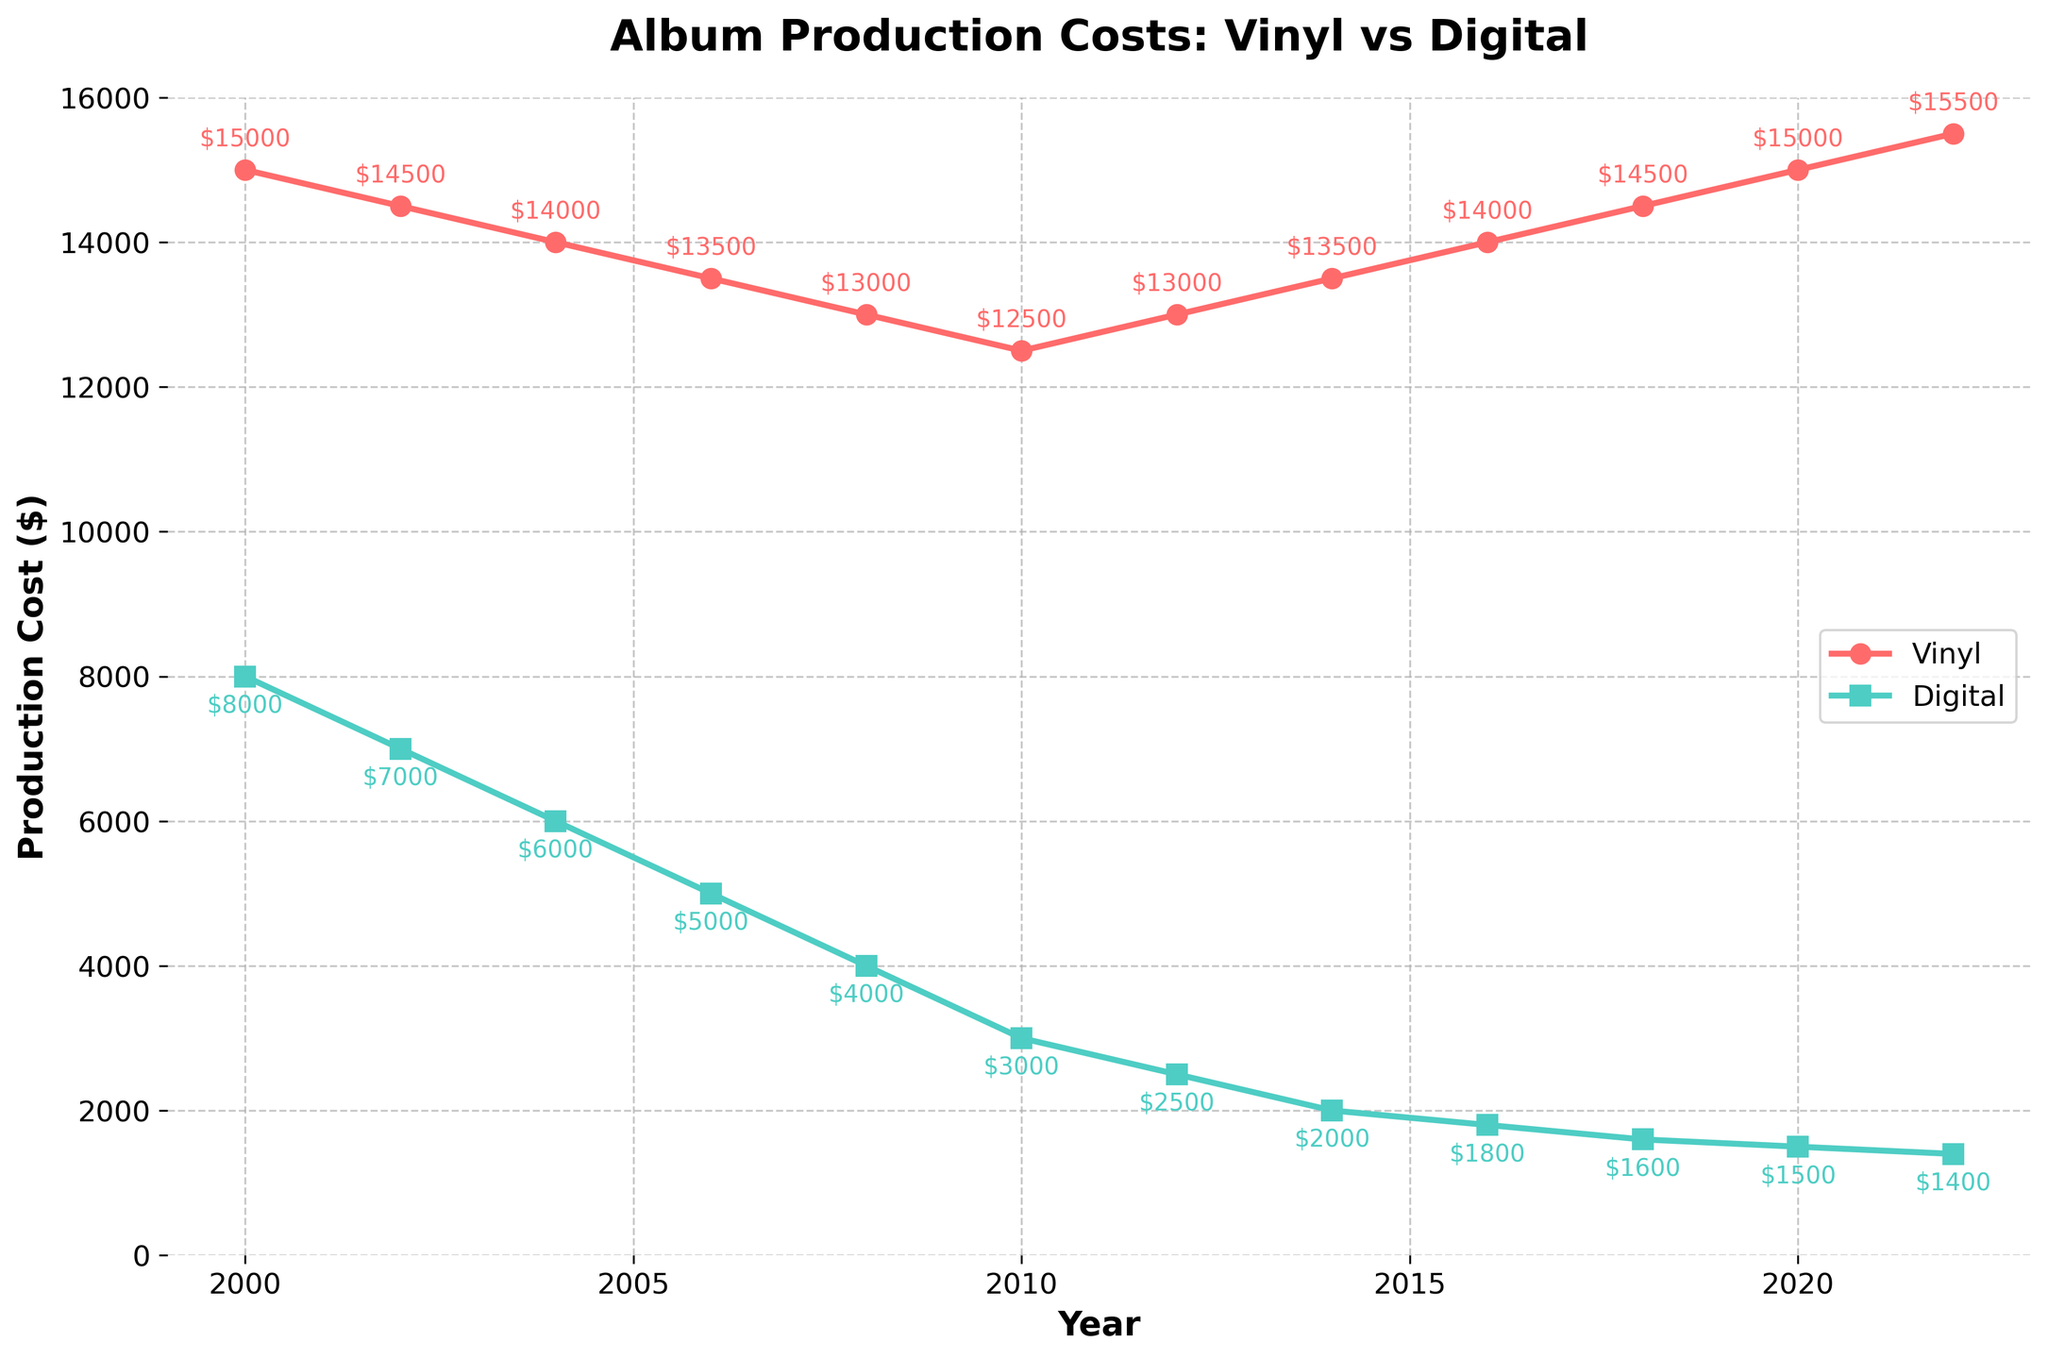What was the production cost for vinyl in 2008? The figure shows the production cost for vinyl in each year. For 2008, look at the y-axis value corresponding to the year 2008 in the vinyl cost line.
Answer: $13,000 How did the production cost for digital formats change from 2000 to 2020? To find the change, subtract the cost in 2020 from the cost in 2000 for digital formats: $8,000 in 2000 to $1,500 in 2020.
Answer: Decreased by $6,500 When did the production cost for vinyl start rising after consistently declining? Observe the trend line for vinyl production costs. The cost started rising after it hit its lowest point in 2010, beginning to rise again from 2012.
Answer: 2012 What is the difference between vinyl and digital production costs in 2022? Locate the production costs for both vinyl and digital formats in 2022: $15,500 for vinyl and $1,400 for digital. The difference is $15,500 - $1,400.
Answer: $14,100 During which years did the production costs for vinyl and digital formats converge the most closely? Examine the figure and identify when the distance between the two lines is the smallest. This appears to be in 2010.
Answer: 2010 Which year had the lowest production cost for digital formats? The figure shows the production cost for digital formats over the years. Identify the lowest point in the digital cost line, which is in 2022.
Answer: 2022 What is the average production cost for vinyl from 2000 to 2022? Add up all the production costs for vinyl over the years and divide by the number of years (12). The sum is $155,000, so the average is $155,000 / 12.
Answer: $12,917 By how much did the digital production cost decrease between 2006 and 2012? Identify the costs for 2006 ($5,000) and 2012 ($2,500) and calculate the decrease: $5,000 - $2,500.
Answer: $2,500 